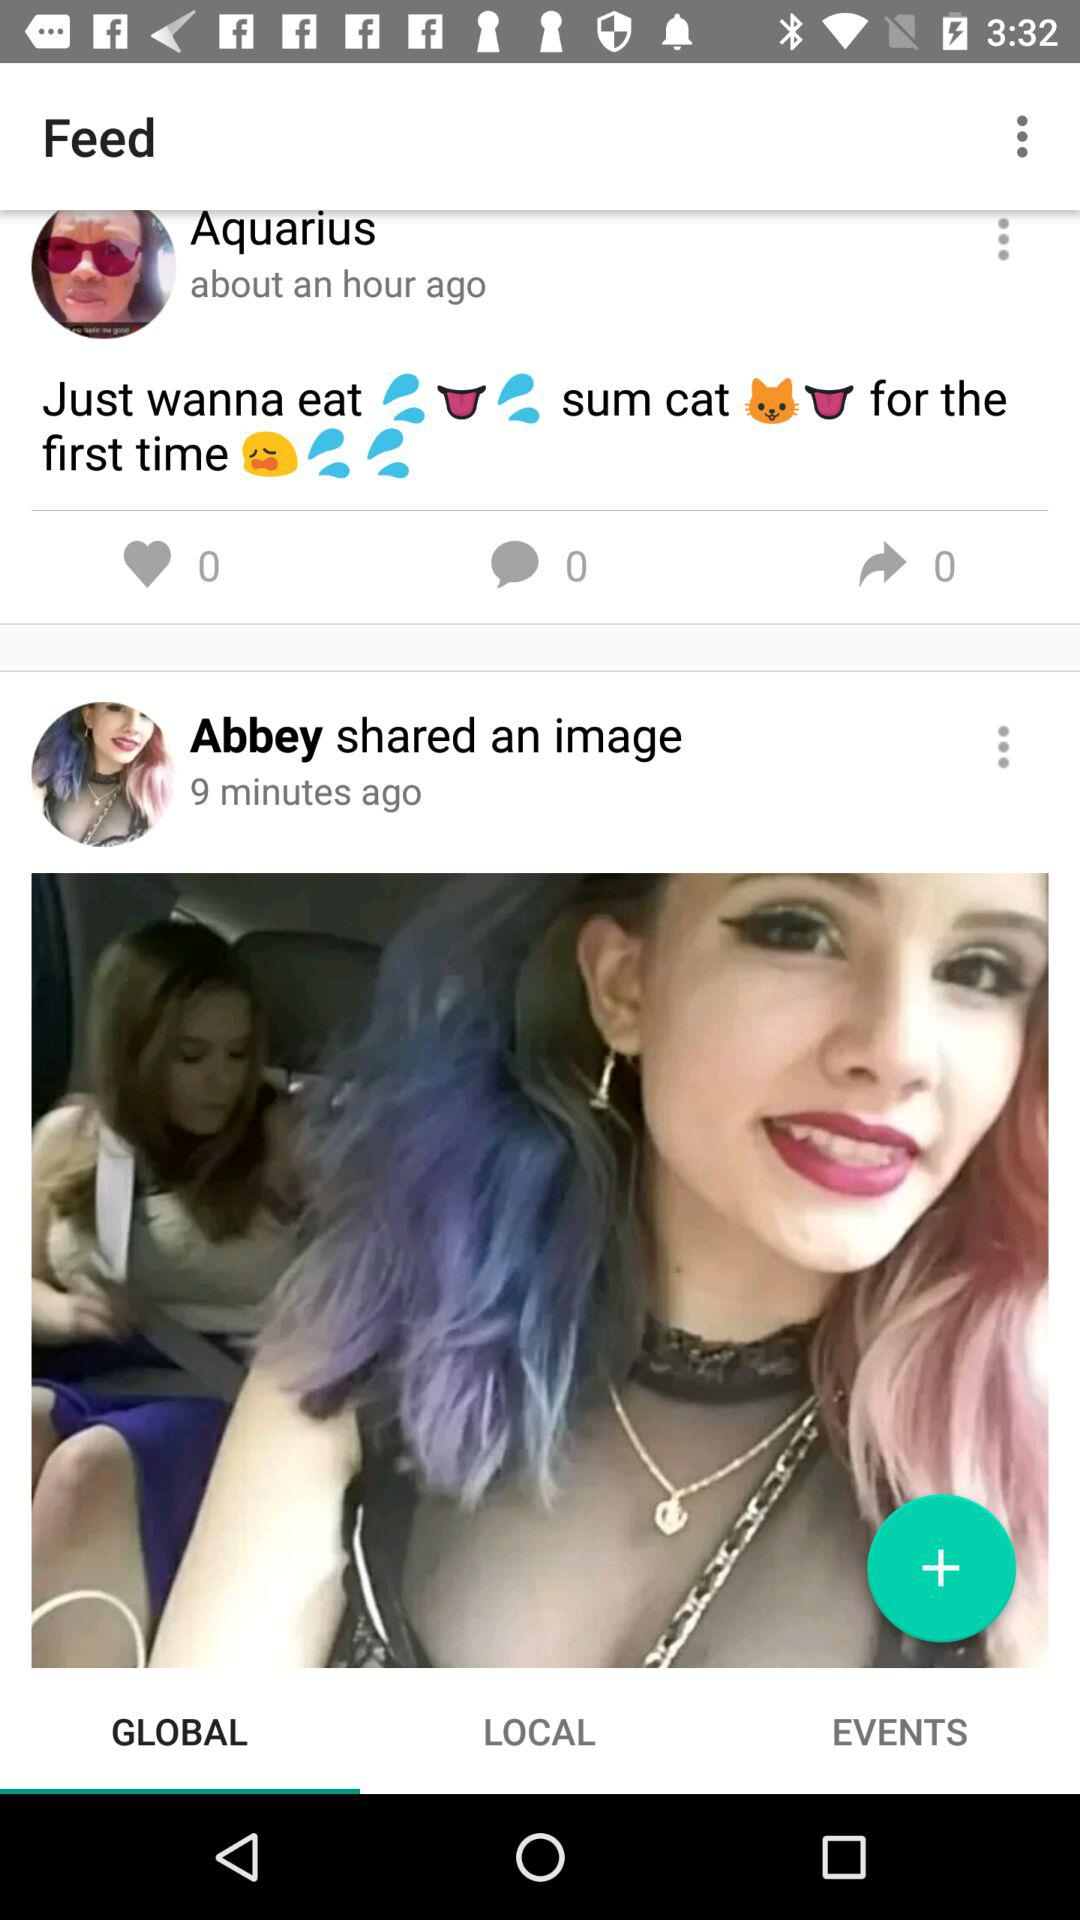How many likes did Aquarius get on her post? Aquarius gets 0 likes. 